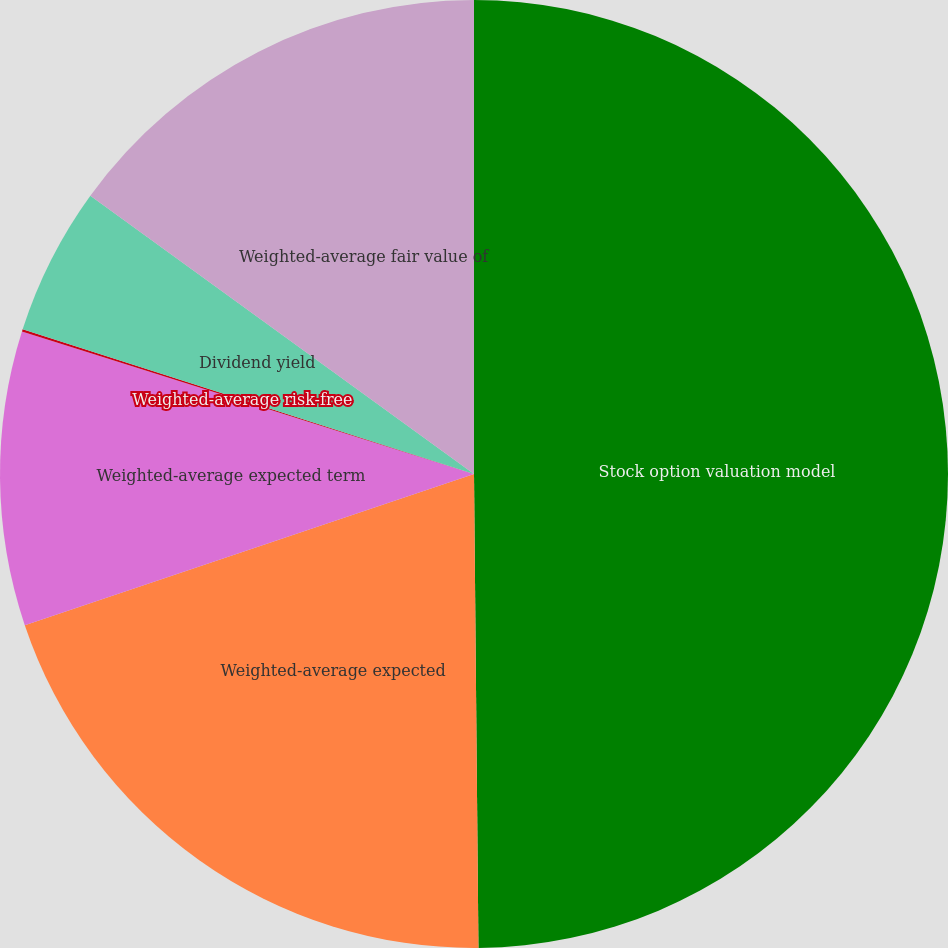<chart> <loc_0><loc_0><loc_500><loc_500><pie_chart><fcel>Stock option valuation model<fcel>Weighted-average expected<fcel>Weighted-average expected term<fcel>Weighted-average risk-free<fcel>Dividend yield<fcel>Weighted-average fair value of<nl><fcel>49.85%<fcel>19.98%<fcel>10.03%<fcel>0.08%<fcel>5.05%<fcel>15.01%<nl></chart> 